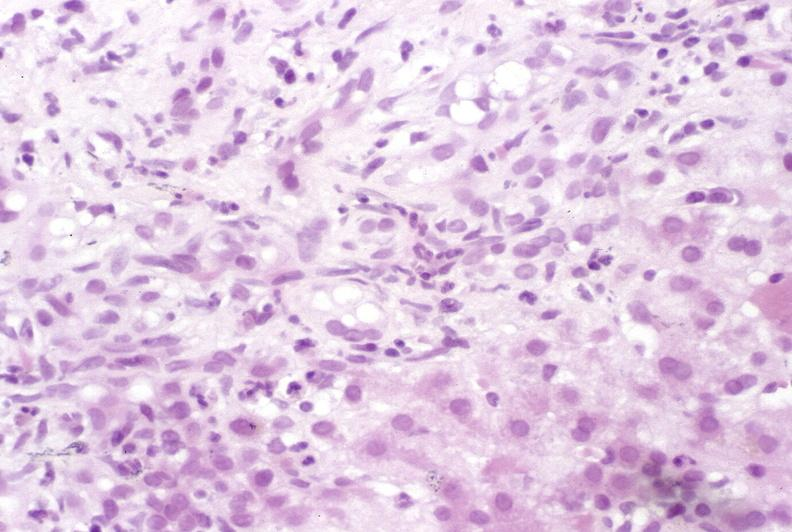s this close-up of cut surface infiltrates present?
Answer the question using a single word or phrase. No 